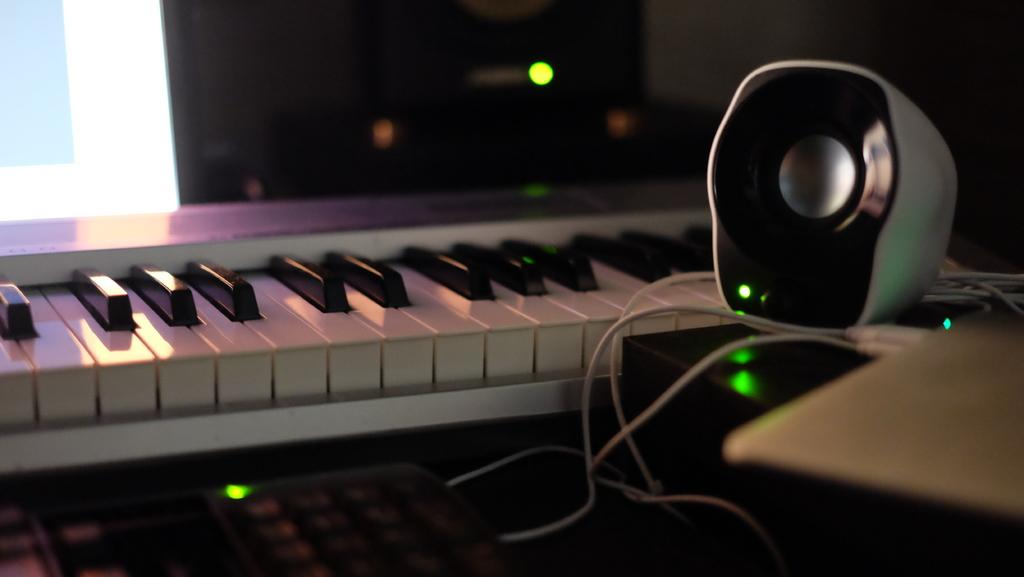Where was the image taken? The image was taken inside a room. What furniture is present in the room? There is a table in the room. What electronic devices are on the table? A keyboard, a laptop, and a speaker are on the table. What can be seen in the background of the image? There is a monitor in the background. How many toes are visible on the keyboard in the image? There are no toes visible in the image, as the image features a keyboard and other electronic devices on a table. 